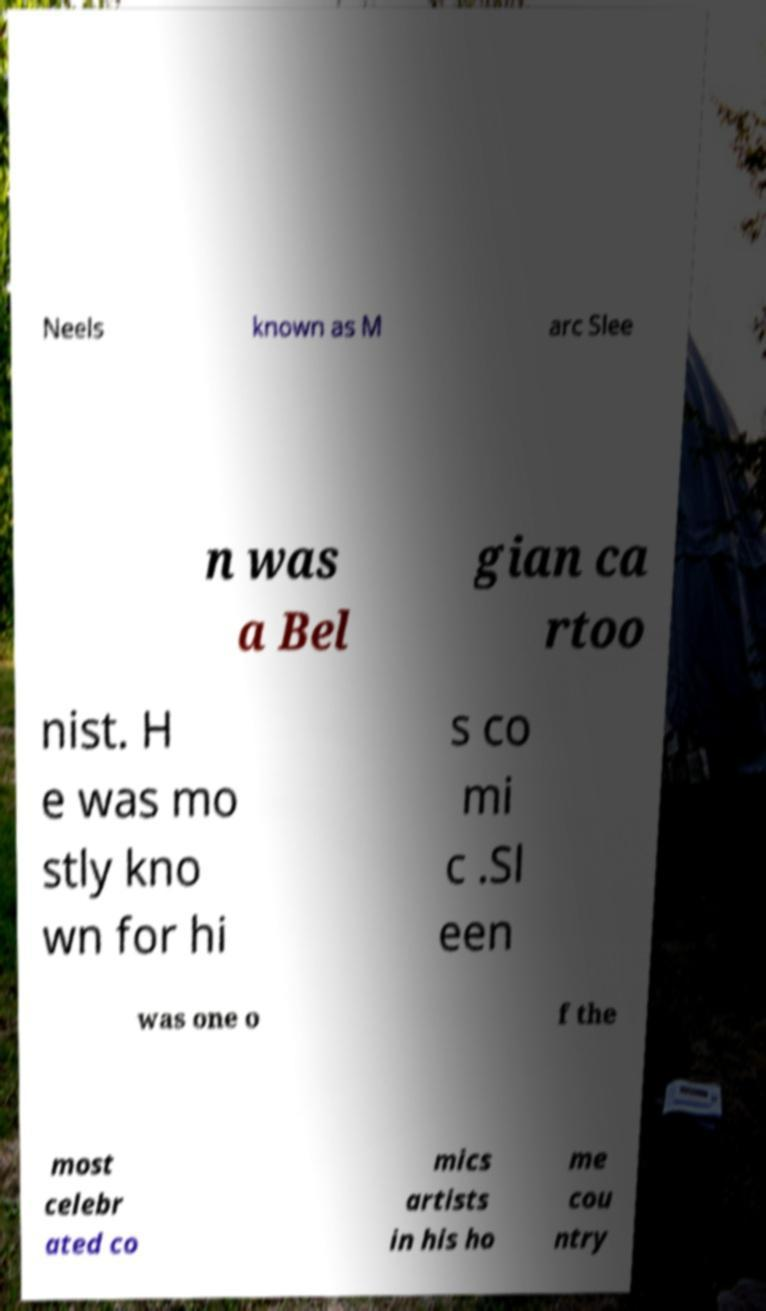Please identify and transcribe the text found in this image. Neels known as M arc Slee n was a Bel gian ca rtoo nist. H e was mo stly kno wn for hi s co mi c .Sl een was one o f the most celebr ated co mics artists in his ho me cou ntry 